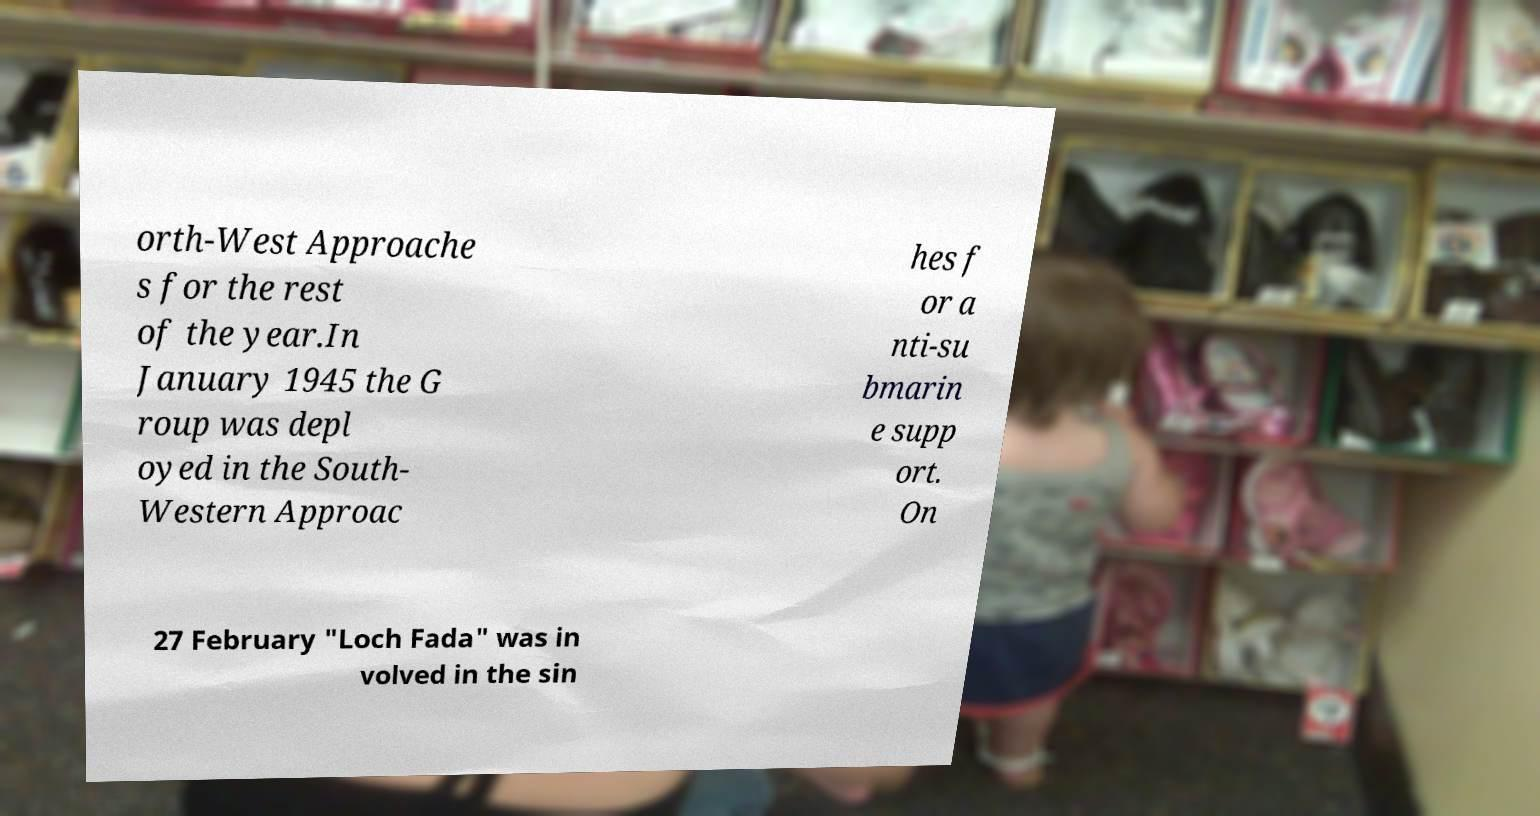I need the written content from this picture converted into text. Can you do that? orth-West Approache s for the rest of the year.In January 1945 the G roup was depl oyed in the South- Western Approac hes f or a nti-su bmarin e supp ort. On 27 February "Loch Fada" was in volved in the sin 